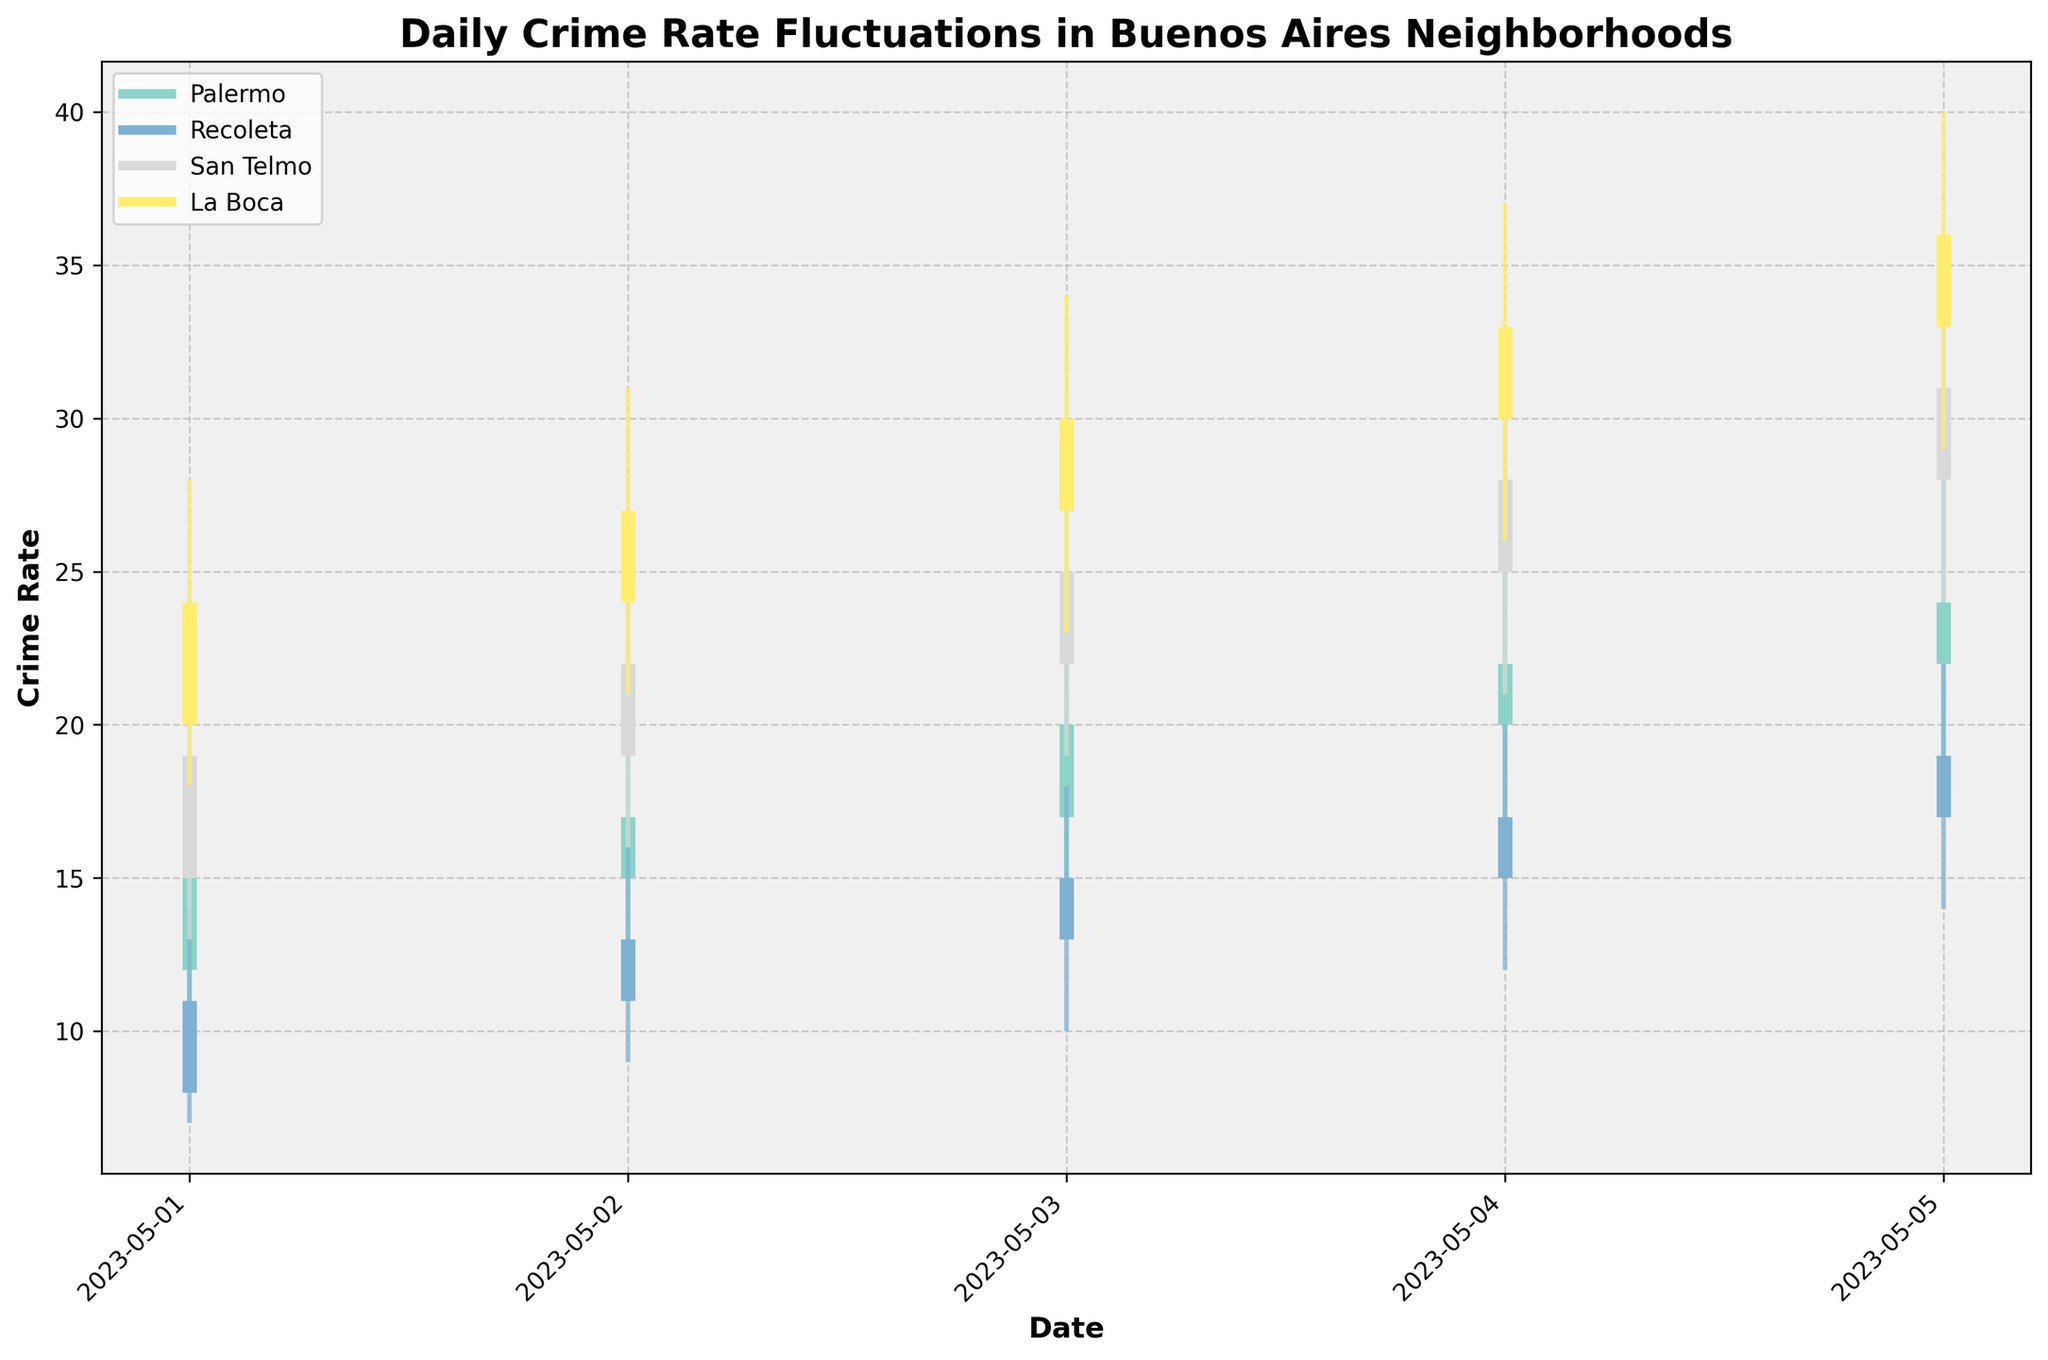What is the title of the figure? The title is at the top of the figure and it reads, "Daily Crime Rate Fluctuations in Buenos Aires Neighborhoods."
Answer: Daily Crime Rate Fluctuations in Buenos Aires Neighborhoods What are the names of the neighborhoods shown in the figure? The neighborhoods' names are listed in the legend of the figure.
Answer: Palermo, Recoleta, San Telmo, La Boca How has the crime rate for Palermo fluctuated over the 5-day period? Referring to the bars for Palermo, the opening and closing rates over the 5-day period are: 12, 15 (May 1); 15, 17 (May 2); 17, 20 (May 3); 20, 22 (May 4); 22, 24 (May 5).
Answer: The crime rate has generally increased over the 5-day period Which neighborhood had the highest crime rate on May 5? On May 5, the crime rates can be seen by the positions of the bars: Palermo (24), Recoleta (19), San Telmo (31), La Boca (36).
Answer: La Boca On which date did Recoleta have the lowest recorded crime rate? Looking at the low points (the bottom of the vertical lines), Recoleta had the lowest crime rate on May 1 (7).
Answer: May 1 Compare the crime rate swings (High-Low) of San Telmo and La Boca on May 4. Which one is larger? San Telmo’s high was 32 and low was 21, so the swing is 11. La Boca’s high was 37 and low was 26, so the swing is 11.
Answer: Both have the same swing (11) What was the average crime rate in Recoleta on May 3, calculated as the average of the open and close rates? The open rate in Recoleta on May 3 was 13 and the close rate was 15. Their average is (13 + 15)/2.
Answer: 14 What was the difference between the highest crime rate in Palermo and La Boca on May 2? On May 2, the highest crime rate in Palermo was 21, and in La Boca was 31. The difference is 31 - 21.
Answer: 10 Which neighborhood had the smallest crime rate increase from May 1 to May 5? Calculate the crime rate increase for each neighborhood: Palermo (24-15=9), Recoleta (19-11=8), San Telmo (31-19=12), La Boca (36-24=12). Recoleta had the smallest increase.
Answer: Recoleta Examine the changes in crime rates from May 1 to May 4 in San Telmo. Did the close prices show an increasing trend? The close rates in San Telmo were 19 (May 1), 22 (May 2), 25 (May 3), 28 (May 4). The close rates increased each day.
Answer: Yes 